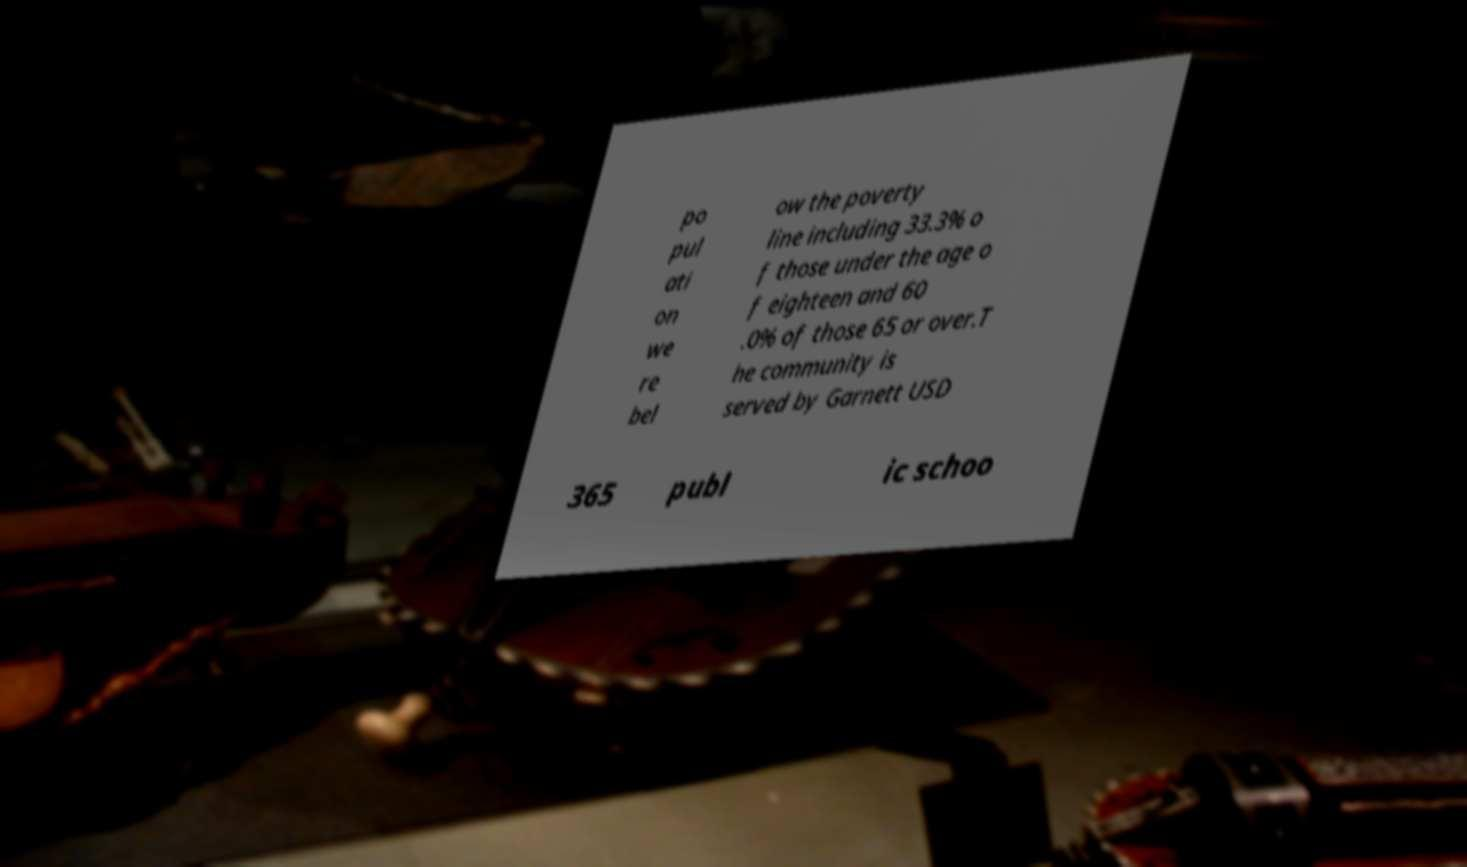What messages or text are displayed in this image? I need them in a readable, typed format. po pul ati on we re bel ow the poverty line including 33.3% o f those under the age o f eighteen and 60 .0% of those 65 or over.T he community is served by Garnett USD 365 publ ic schoo 